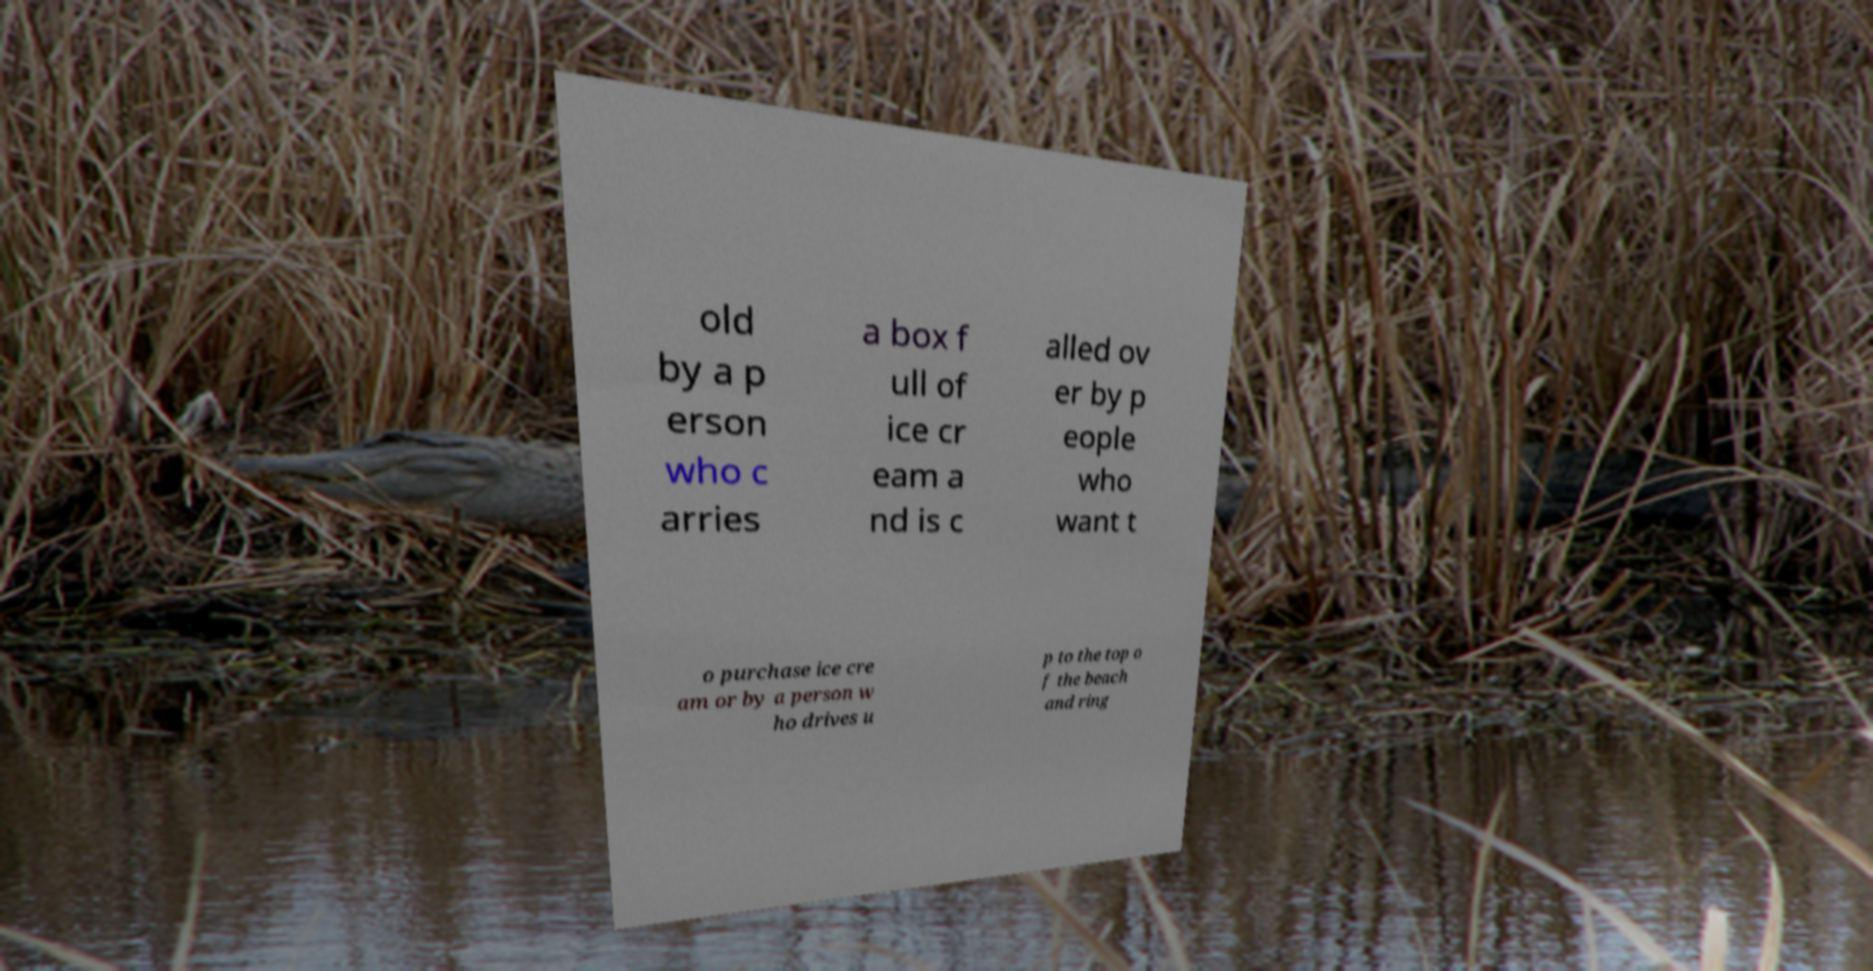Please identify and transcribe the text found in this image. old by a p erson who c arries a box f ull of ice cr eam a nd is c alled ov er by p eople who want t o purchase ice cre am or by a person w ho drives u p to the top o f the beach and ring 